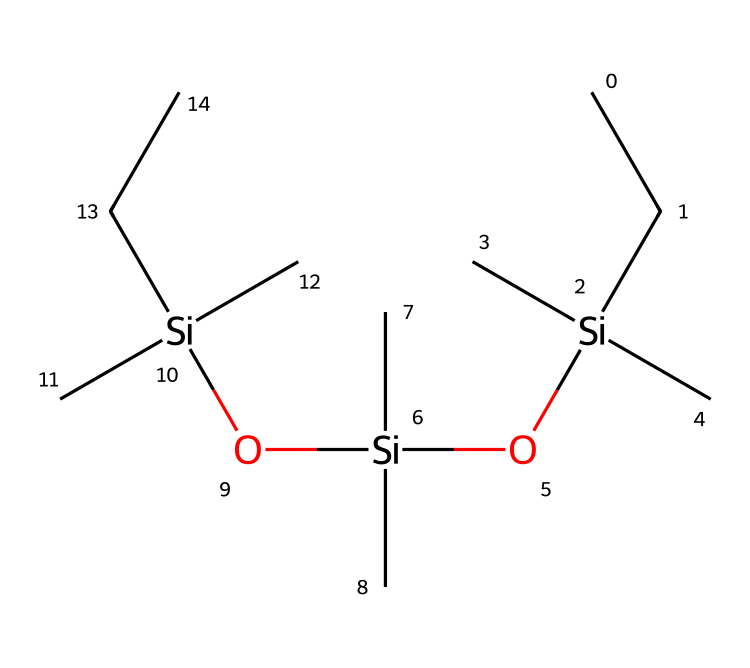What is the total number of silicon atoms in this structure? The SMILES representation shows three silicon atoms: one in each of the three repeating units, indicated by the [Si] symbols.
Answer: three How many oxygen atoms are present in this chemical? The representation includes two oxygen atoms, as indicated by the O symbols in the sequence.
Answer: two What type of chemical bonds connect the silicon atoms to the oxygen atoms? The siloxane linkage features Si-O bonds, which are typical for organosilicon compounds and indicate a covalent bond between silicon and oxygen.
Answer: covalent Is this compound more likely to be hydrophilic or hydrophobic? Given the siloxane structure and the presence of the hydrocarbon chains (C), it suggests that the compound is hydrophobic due to the dominance of carbon chains.
Answer: hydrophobic What is the main functional group present in this compound? The compound features siloxane linkages ([Si]O[Si]), which are characteristic of the siloxane functional group in organosilicon compounds.
Answer: siloxane Why might this compound be beneficial for waterproofing referee uniforms? The presence of the siloxane structure contributes to low surface energy and water-repellent properties, making it effective for waterproofing applications.
Answer: water-repellent How does the branching of carbon chains affect the properties of this compound? The branching of carbon chains can enhance flexibility and reduce the packing efficiency of the polymer, impacting its overall waterproofing capabilities and versatility in application.
Answer: flexibility 